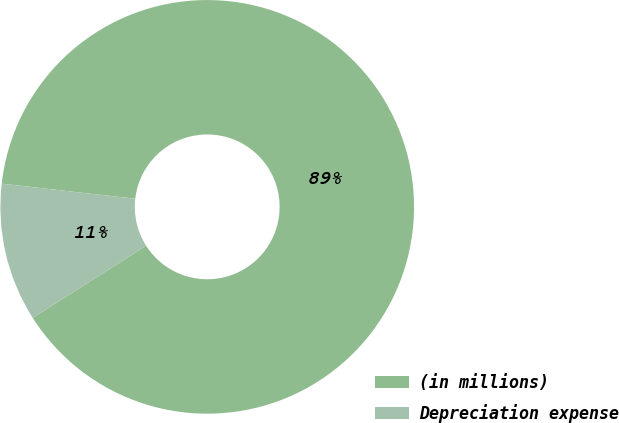<chart> <loc_0><loc_0><loc_500><loc_500><pie_chart><fcel>(in millions)<fcel>Depreciation expense<nl><fcel>89.19%<fcel>10.81%<nl></chart> 